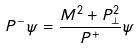Convert formula to latex. <formula><loc_0><loc_0><loc_500><loc_500>P ^ { - } \psi = \frac { M ^ { 2 } + P _ { \perp } ^ { 2 } } { P ^ { + } } \psi</formula> 